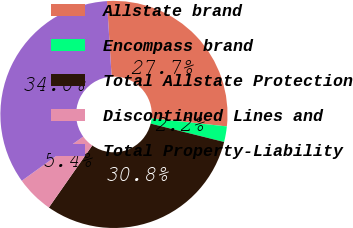<chart> <loc_0><loc_0><loc_500><loc_500><pie_chart><fcel>Allstate brand<fcel>Encompass brand<fcel>Total Allstate Protection<fcel>Discontinued Lines and<fcel>Total Property-Liability<nl><fcel>27.66%<fcel>2.22%<fcel>30.81%<fcel>5.36%<fcel>33.95%<nl></chart> 